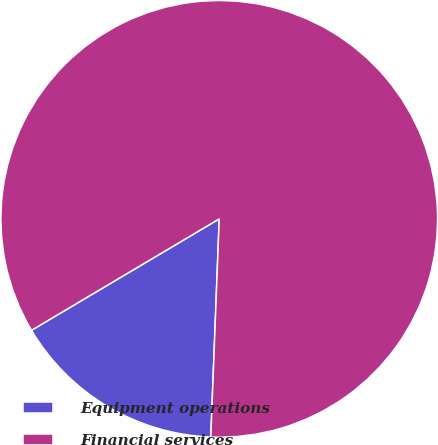Convert chart. <chart><loc_0><loc_0><loc_500><loc_500><pie_chart><fcel>Equipment operations<fcel>Financial services<nl><fcel>15.86%<fcel>84.14%<nl></chart> 